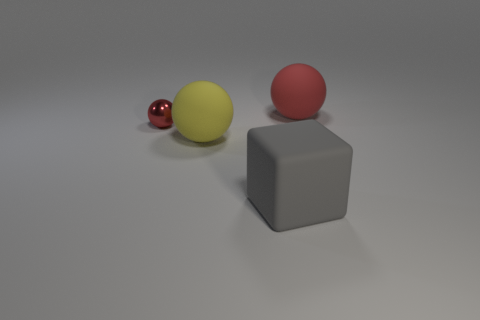Is the large object behind the small metallic object made of the same material as the yellow object?
Ensure brevity in your answer.  Yes. What number of other objects are there of the same shape as the large gray matte thing?
Make the answer very short. 0. There is a big sphere that is in front of the red object to the right of the red metallic thing; how many big gray matte cubes are on the left side of it?
Your answer should be compact. 0. The big rubber thing on the right side of the cube is what color?
Provide a succinct answer. Red. There is a matte object on the left side of the large gray thing; is it the same color as the small ball?
Make the answer very short. No. The red metal thing that is the same shape as the red matte object is what size?
Offer a terse response. Small. Is there anything else that has the same size as the shiny thing?
Your answer should be compact. No. There is a thing behind the red ball that is to the left of the large rubber object that is behind the tiny metallic object; what is it made of?
Provide a succinct answer. Rubber. Are there more metal things that are right of the yellow rubber object than cubes that are to the left of the gray object?
Provide a succinct answer. No. Is the size of the gray thing the same as the red rubber object?
Offer a terse response. Yes. 